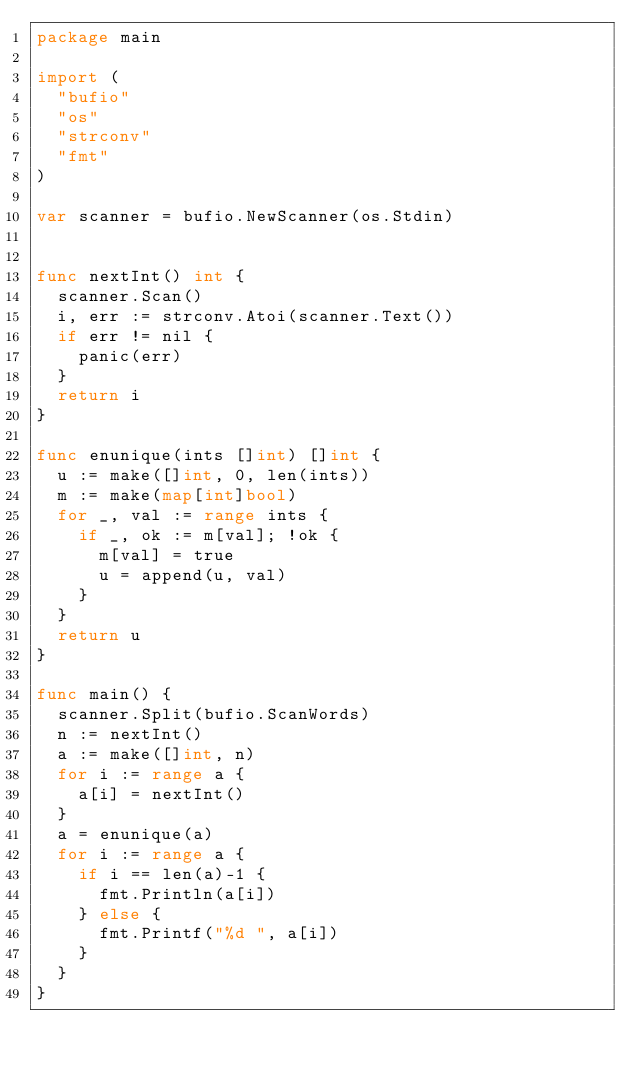<code> <loc_0><loc_0><loc_500><loc_500><_Go_>package main

import (
	"bufio"
	"os"
	"strconv"
	"fmt"
)

var scanner = bufio.NewScanner(os.Stdin)


func nextInt() int {
	scanner.Scan()
	i, err := strconv.Atoi(scanner.Text())
	if err != nil {
		panic(err)
	}
	return i
}

func enunique(ints []int) []int {
	u := make([]int, 0, len(ints))
	m := make(map[int]bool)
	for _, val := range ints {
		if _, ok := m[val]; !ok {
			m[val] = true
			u = append(u, val)
		}
	}
	return u
}

func main() {
	scanner.Split(bufio.ScanWords)
	n := nextInt()
	a := make([]int, n)
	for i := range a {
		a[i] = nextInt()
	}
	a = enunique(a)
	for i := range a {
		if i == len(a)-1 {
			fmt.Println(a[i])
		} else {
			fmt.Printf("%d ", a[i])
		}
	}
}
</code> 